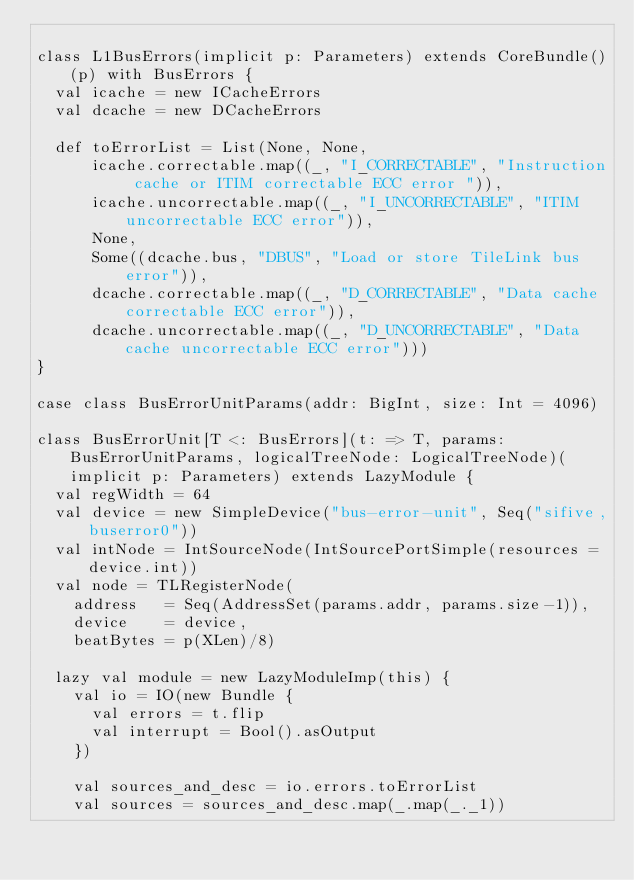Convert code to text. <code><loc_0><loc_0><loc_500><loc_500><_Scala_>
class L1BusErrors(implicit p: Parameters) extends CoreBundle()(p) with BusErrors {
  val icache = new ICacheErrors
  val dcache = new DCacheErrors

  def toErrorList = List(None, None,
      icache.correctable.map((_, "I_CORRECTABLE", "Instruction cache or ITIM correctable ECC error ")),
      icache.uncorrectable.map((_, "I_UNCORRECTABLE", "ITIM uncorrectable ECC error")),
      None,
      Some((dcache.bus, "DBUS", "Load or store TileLink bus error")),
      dcache.correctable.map((_, "D_CORRECTABLE", "Data cache correctable ECC error")),
      dcache.uncorrectable.map((_, "D_UNCORRECTABLE", "Data cache uncorrectable ECC error")))
}

case class BusErrorUnitParams(addr: BigInt, size: Int = 4096)

class BusErrorUnit[T <: BusErrors](t: => T, params: BusErrorUnitParams, logicalTreeNode: LogicalTreeNode)(implicit p: Parameters) extends LazyModule {
  val regWidth = 64
  val device = new SimpleDevice("bus-error-unit", Seq("sifive,buserror0"))
  val intNode = IntSourceNode(IntSourcePortSimple(resources = device.int))
  val node = TLRegisterNode(
    address   = Seq(AddressSet(params.addr, params.size-1)),
    device    = device,
    beatBytes = p(XLen)/8)

  lazy val module = new LazyModuleImp(this) {
    val io = IO(new Bundle {
      val errors = t.flip
      val interrupt = Bool().asOutput
    })

    val sources_and_desc = io.errors.toErrorList
    val sources = sources_and_desc.map(_.map(_._1))</code> 